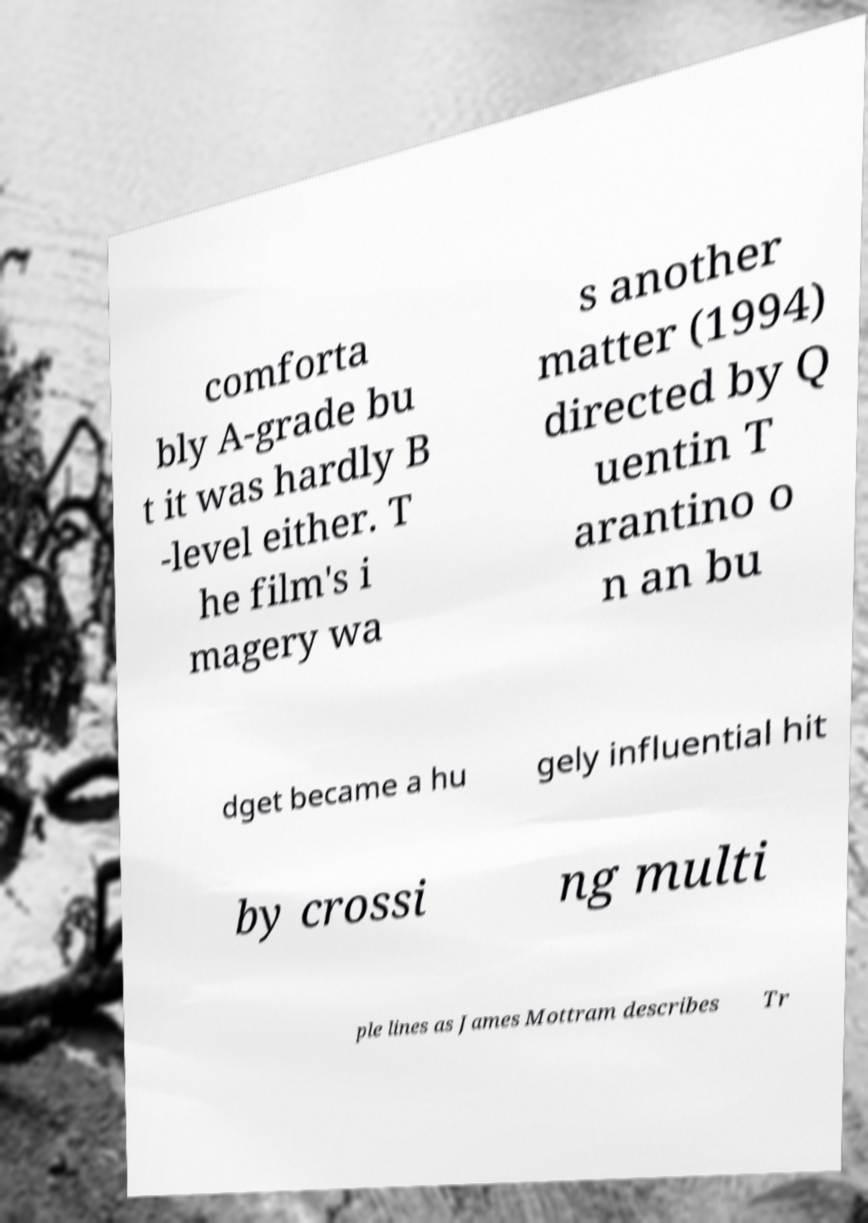Could you extract and type out the text from this image? comforta bly A-grade bu t it was hardly B -level either. T he film's i magery wa s another matter (1994) directed by Q uentin T arantino o n an bu dget became a hu gely influential hit by crossi ng multi ple lines as James Mottram describes Tr 